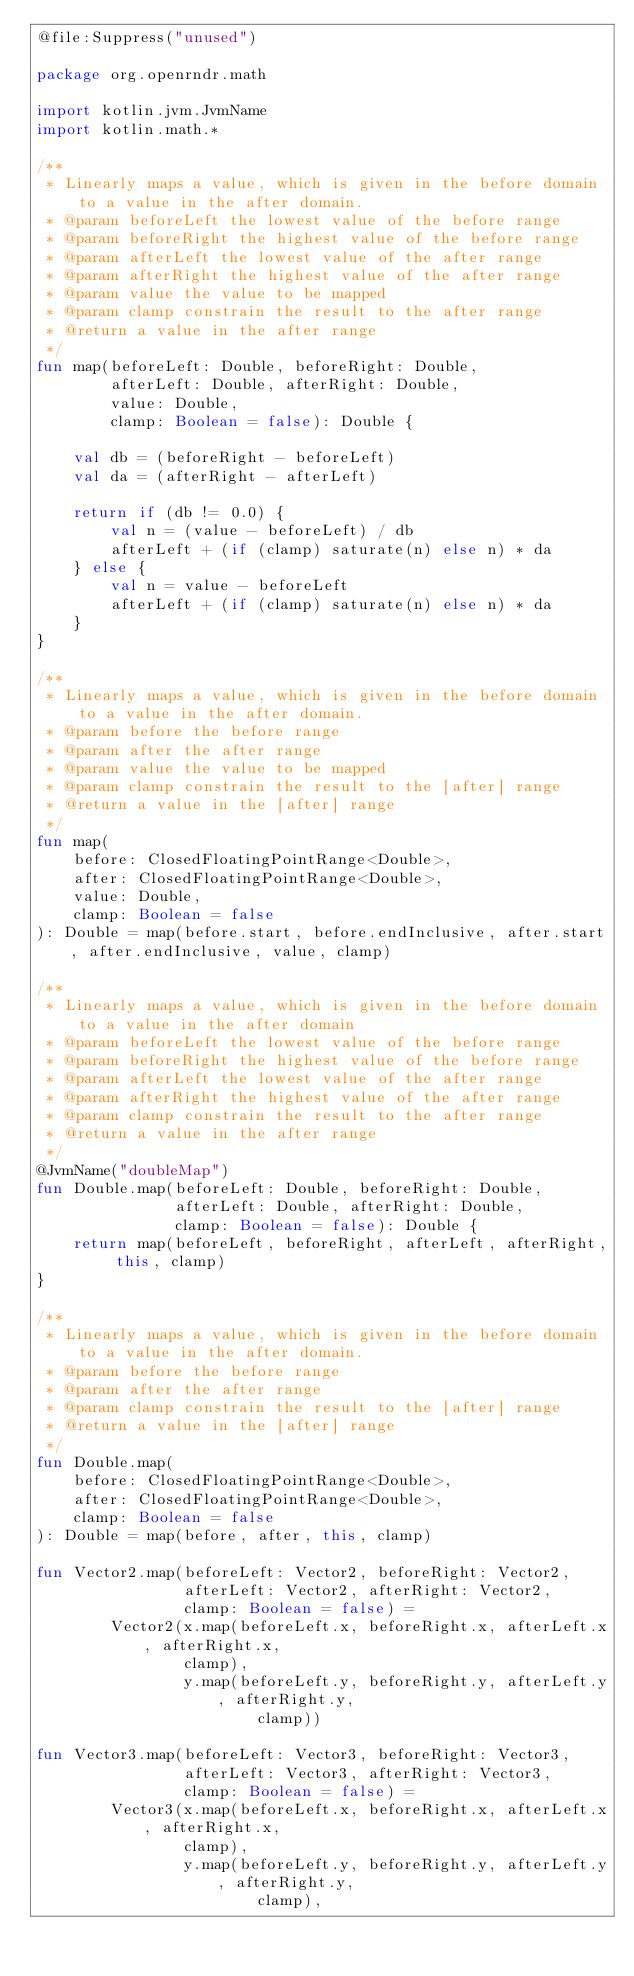Convert code to text. <code><loc_0><loc_0><loc_500><loc_500><_Kotlin_>@file:Suppress("unused")

package org.openrndr.math

import kotlin.jvm.JvmName
import kotlin.math.*

/**
 * Linearly maps a value, which is given in the before domain to a value in the after domain.
 * @param beforeLeft the lowest value of the before range
 * @param beforeRight the highest value of the before range
 * @param afterLeft the lowest value of the after range
 * @param afterRight the highest value of the after range
 * @param value the value to be mapped
 * @param clamp constrain the result to the after range
 * @return a value in the after range
 */
fun map(beforeLeft: Double, beforeRight: Double,
        afterLeft: Double, afterRight: Double,
        value: Double,
        clamp: Boolean = false): Double {

    val db = (beforeRight - beforeLeft)
    val da = (afterRight - afterLeft)

    return if (db != 0.0) {
        val n = (value - beforeLeft) / db
        afterLeft + (if (clamp) saturate(n) else n) * da
    } else {
        val n = value - beforeLeft
        afterLeft + (if (clamp) saturate(n) else n) * da
    }
}

/**
 * Linearly maps a value, which is given in the before domain to a value in the after domain.
 * @param before the before range
 * @param after the after range
 * @param value the value to be mapped
 * @param clamp constrain the result to the [after] range
 * @return a value in the [after] range
 */
fun map(
    before: ClosedFloatingPointRange<Double>,
    after: ClosedFloatingPointRange<Double>,
    value: Double,
    clamp: Boolean = false
): Double = map(before.start, before.endInclusive, after.start, after.endInclusive, value, clamp)

/**
 * Linearly maps a value, which is given in the before domain to a value in the after domain
 * @param beforeLeft the lowest value of the before range
 * @param beforeRight the highest value of the before range
 * @param afterLeft the lowest value of the after range
 * @param afterRight the highest value of the after range
 * @param clamp constrain the result to the after range
 * @return a value in the after range
 */
@JvmName("doubleMap")
fun Double.map(beforeLeft: Double, beforeRight: Double,
               afterLeft: Double, afterRight: Double,
               clamp: Boolean = false): Double {
    return map(beforeLeft, beforeRight, afterLeft, afterRight, this, clamp)
}

/**
 * Linearly maps a value, which is given in the before domain to a value in the after domain.
 * @param before the before range
 * @param after the after range
 * @param clamp constrain the result to the [after] range
 * @return a value in the [after] range
 */
fun Double.map(
    before: ClosedFloatingPointRange<Double>,
    after: ClosedFloatingPointRange<Double>,
    clamp: Boolean = false
): Double = map(before, after, this, clamp)

fun Vector2.map(beforeLeft: Vector2, beforeRight: Vector2,
                afterLeft: Vector2, afterRight: Vector2,
                clamp: Boolean = false) =
        Vector2(x.map(beforeLeft.x, beforeRight.x, afterLeft.x, afterRight.x,
                clamp),
                y.map(beforeLeft.y, beforeRight.y, afterLeft.y, afterRight.y,
                        clamp))

fun Vector3.map(beforeLeft: Vector3, beforeRight: Vector3,
                afterLeft: Vector3, afterRight: Vector3,
                clamp: Boolean = false) =
        Vector3(x.map(beforeLeft.x, beforeRight.x, afterLeft.x, afterRight.x,
                clamp),
                y.map(beforeLeft.y, beforeRight.y, afterLeft.y, afterRight.y,
                        clamp),</code> 